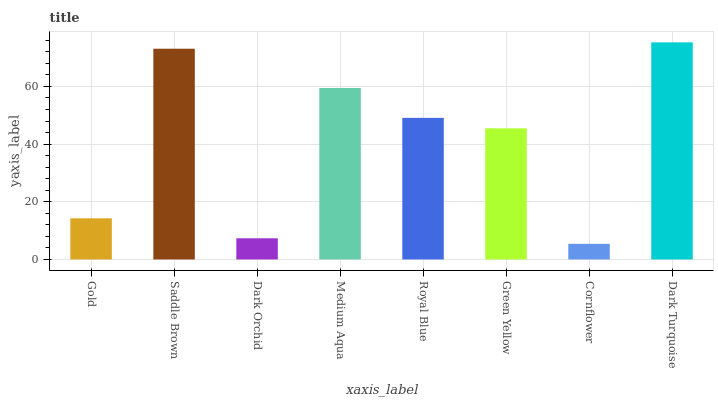Is Dark Turquoise the maximum?
Answer yes or no. Yes. Is Saddle Brown the minimum?
Answer yes or no. No. Is Saddle Brown the maximum?
Answer yes or no. No. Is Saddle Brown greater than Gold?
Answer yes or no. Yes. Is Gold less than Saddle Brown?
Answer yes or no. Yes. Is Gold greater than Saddle Brown?
Answer yes or no. No. Is Saddle Brown less than Gold?
Answer yes or no. No. Is Royal Blue the high median?
Answer yes or no. Yes. Is Green Yellow the low median?
Answer yes or no. Yes. Is Dark Turquoise the high median?
Answer yes or no. No. Is Cornflower the low median?
Answer yes or no. No. 